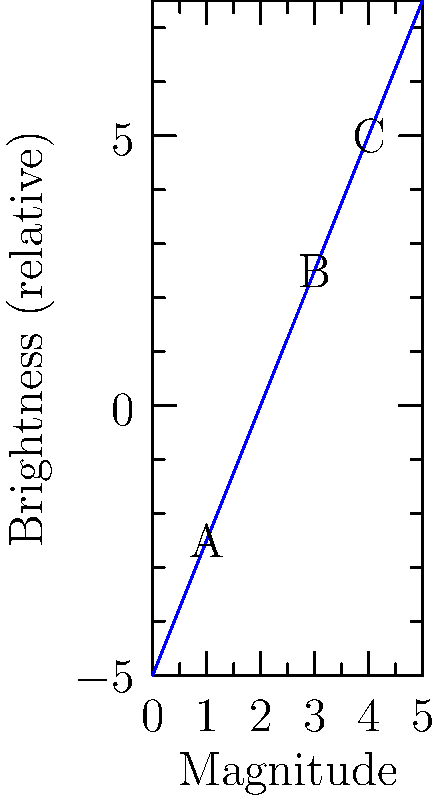In the context of early Finnish women's political movements, consider the following analogy: If the influence of key female figures were represented as stars, with their political impact measured on a magnitude scale similar to stellar brightness, examine the graph above. Which "political star" (A, B, or C) would have had the most significant impact on the movement, and how much brighter (in terms of magnitude difference) would it be compared to the least influential figure? To answer this question, we need to understand the inverse relationship between magnitude and brightness in astronomy, which we're using as an analogy for political influence:

1. In the magnitude scale, lower numbers indicate brighter stars (or in our analogy, more influential figures).
2. The scale is logarithmic, where a difference of 5 magnitudes corresponds to a factor of 100 in brightness.

Let's analyze the "political stars" on the graph:

1. Star A: Magnitude 1, Brightness -2.5
2. Star B: Magnitude 3, Brightness 2.5
3. Star C: Magnitude 4, Brightness 5

Star A has the lowest magnitude, therefore it represents the most influential figure in our analogy.

To calculate the magnitude difference:
- Most influential (A): Magnitude 1
- Least influential (C): Magnitude 4
- Difference: 4 - 1 = 3 magnitudes

The difference of 3 magnitudes corresponds to a brightness ratio of about 15.8 times (calculated as $2.512^3$, where 2.512 is the fifth root of 100).
Answer: Star A; 3 magnitudes brighter (15.8 times more influential) 